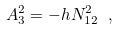<formula> <loc_0><loc_0><loc_500><loc_500>A _ { 3 } ^ { 2 } = - h N _ { 1 2 } ^ { 2 } \ ,</formula> 